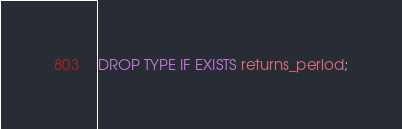Convert code to text. <code><loc_0><loc_0><loc_500><loc_500><_SQL_>

DROP TYPE IF EXISTS returns_period;
</code> 